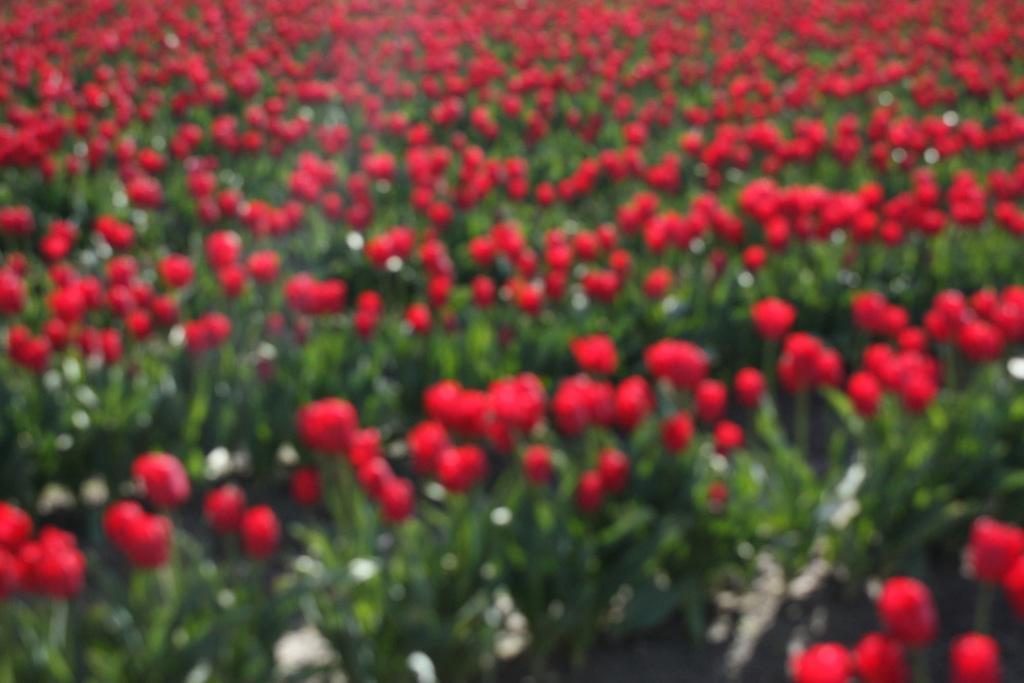Can you describe this image briefly? In this image we can see the red color flower plants. 